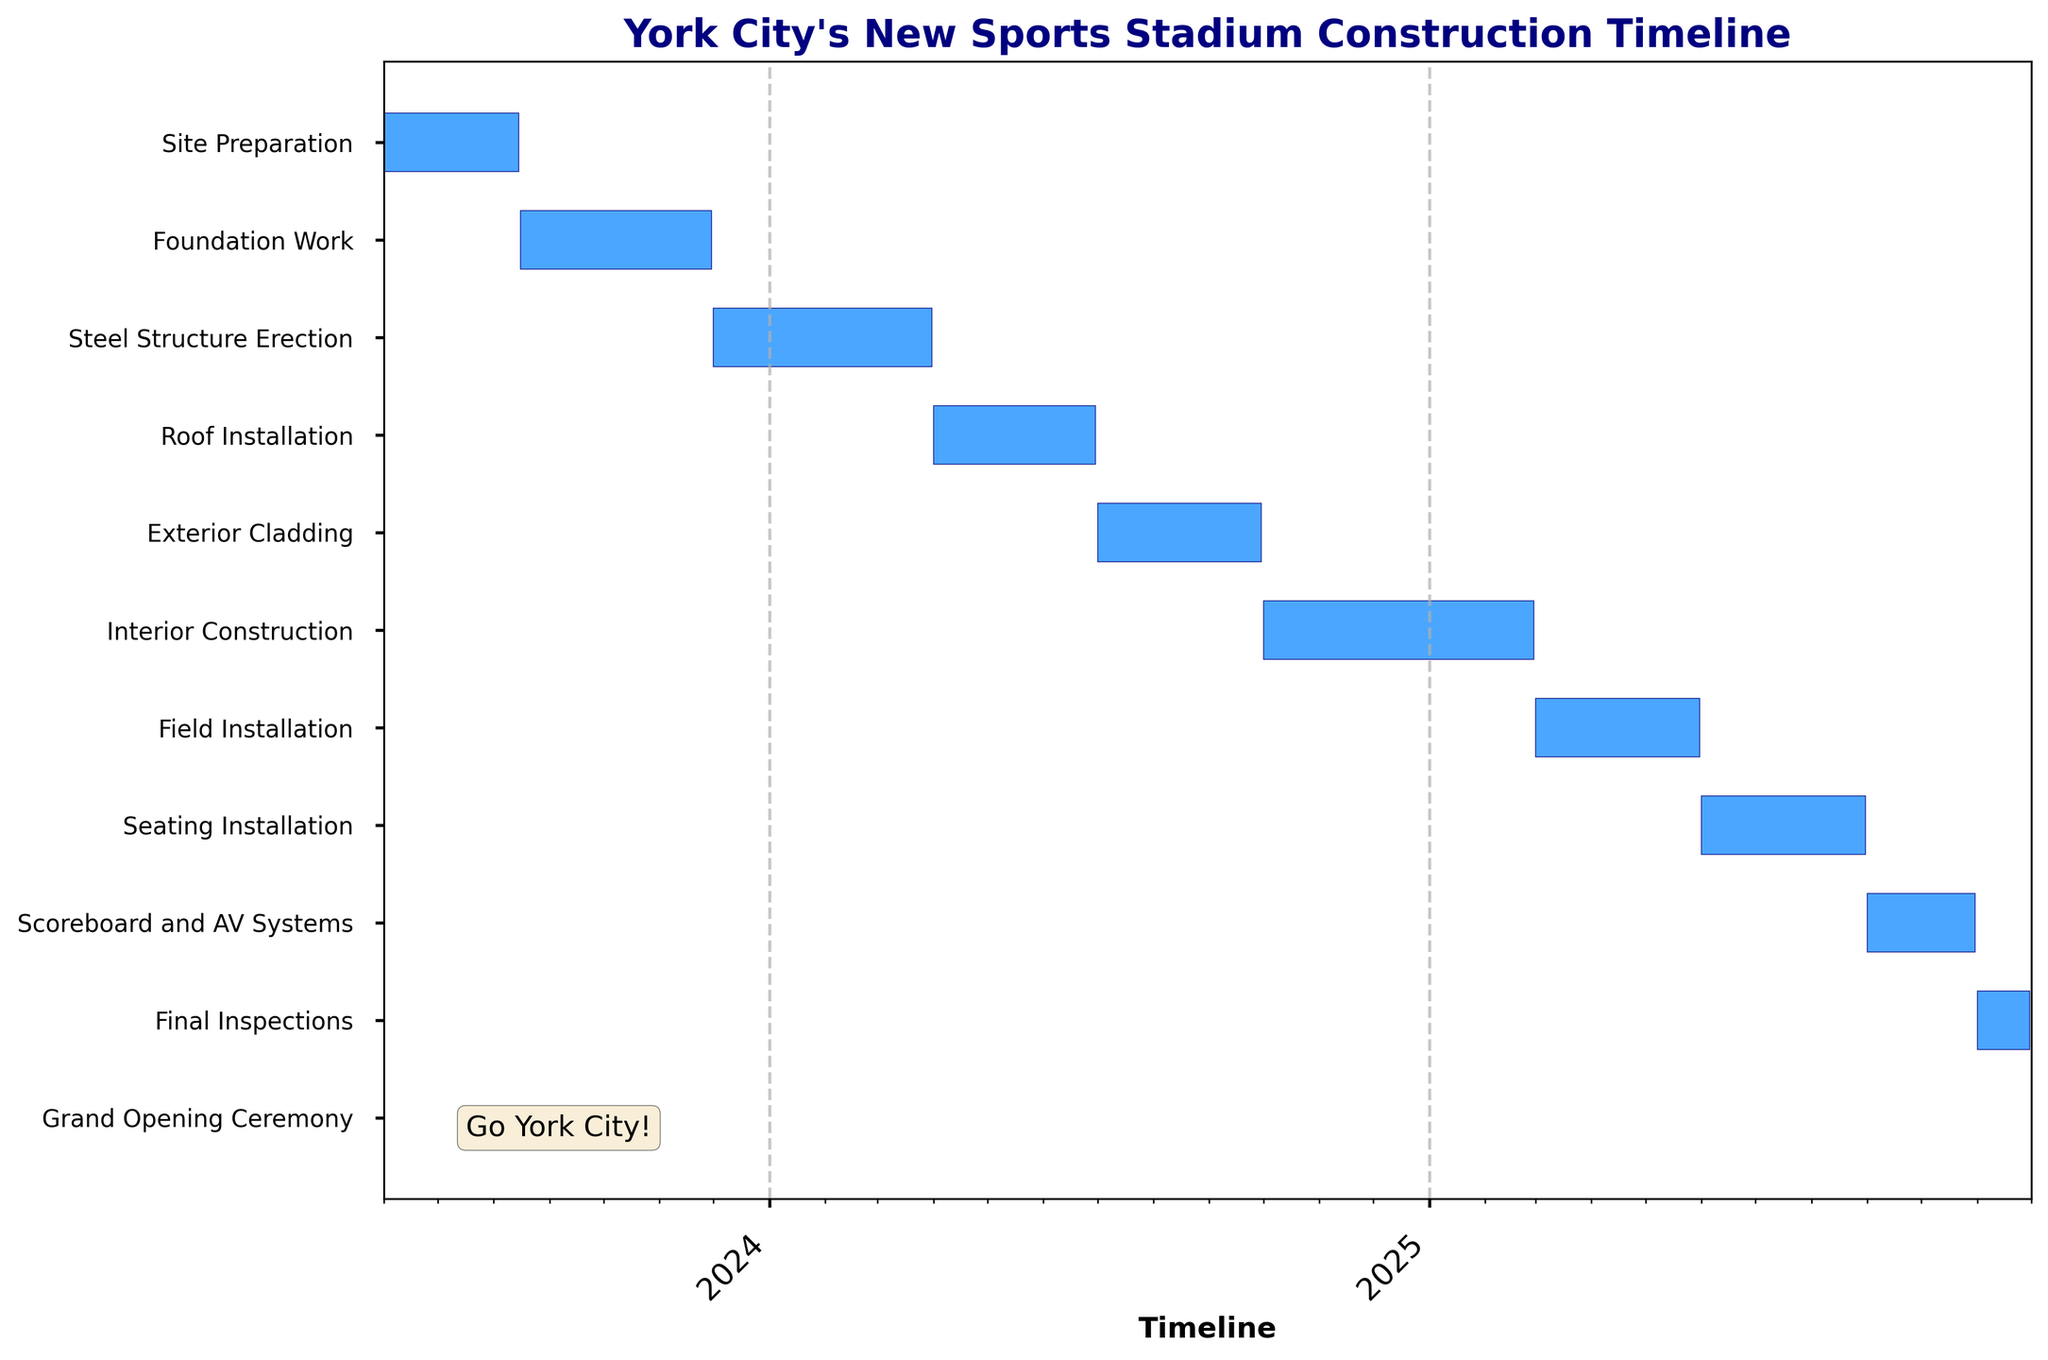What's the title of the figure? The title is located at the top of the plot and usually describes the chart's main purpose or subject. In this case, it indicates the timeline for building York City's new sports stadium.
Answer: York City's New Sports Stadium Construction Timeline How long does the "Roof Installation" task last? To determine the duration of the "Roof Installation" task, find the start date and end date for this task. Then, calculate the difference between these dates.
Answer: Approximately 3 months What are the start and end dates for the "Foundation Work"? Identify the bars for "Foundation Work" on the Gantt chart and note their starting and ending points on the x-axis, which correspond to the start and end dates respectively.
Answer: August 16, 2023 - November 30, 2023 Which task takes the longest time in the project? Compare the lengths of all the horizontal bars in the chart, as the length of each bar represents the duration of the task. The longest bar corresponds to the longest task.
Answer: Interior Construction How does the duration of "Field Installation" compare to "Seating Installation"? Calculate the length of both "Field Installation" and "Seating Installation" bars on the chart by noting their start and end dates, then compare these durations.
Answer: Field Installation is shorter What is the total number of major tasks listed in the chart? Count all the unique tasks (each represented by a horizontal bar) listed along the y-axis of the Gantt chart.
Answer: 11 tasks Which tasks fall entirely within the year 2024? Look for tasks that have both their start and end dates within the year 2024 by examining the x-axis dates. These tasks don't extend before January 2024 or after December 2024.
Answer: Steel Structure Erection, Roof Installation, Exterior Cladding When does the "Grand Opening Ceremony" take place? Locate the "Grand Opening Ceremony" task on the y-axis and note the corresponding date on the x-axis where its bar is positioned.
Answer: December 1, 2025 Which tasks have overlapping time frames in their schedules? Identify tasks that have bars starting before the end date of another task, indicating overlap. For example, tasks with overlapping horizontal positions on the timeline.
Answer: Foundation Work and Steel Structure Erection; Interior Construction and Field Installation What's the combined duration of "Steel Structure Erection" and "Roof Installation"? First, calculate the duration for both tasks separately by finding the difference between their start and end dates. Then sum these durations to get the total combined duration.
Answer: Approximately 7 months 